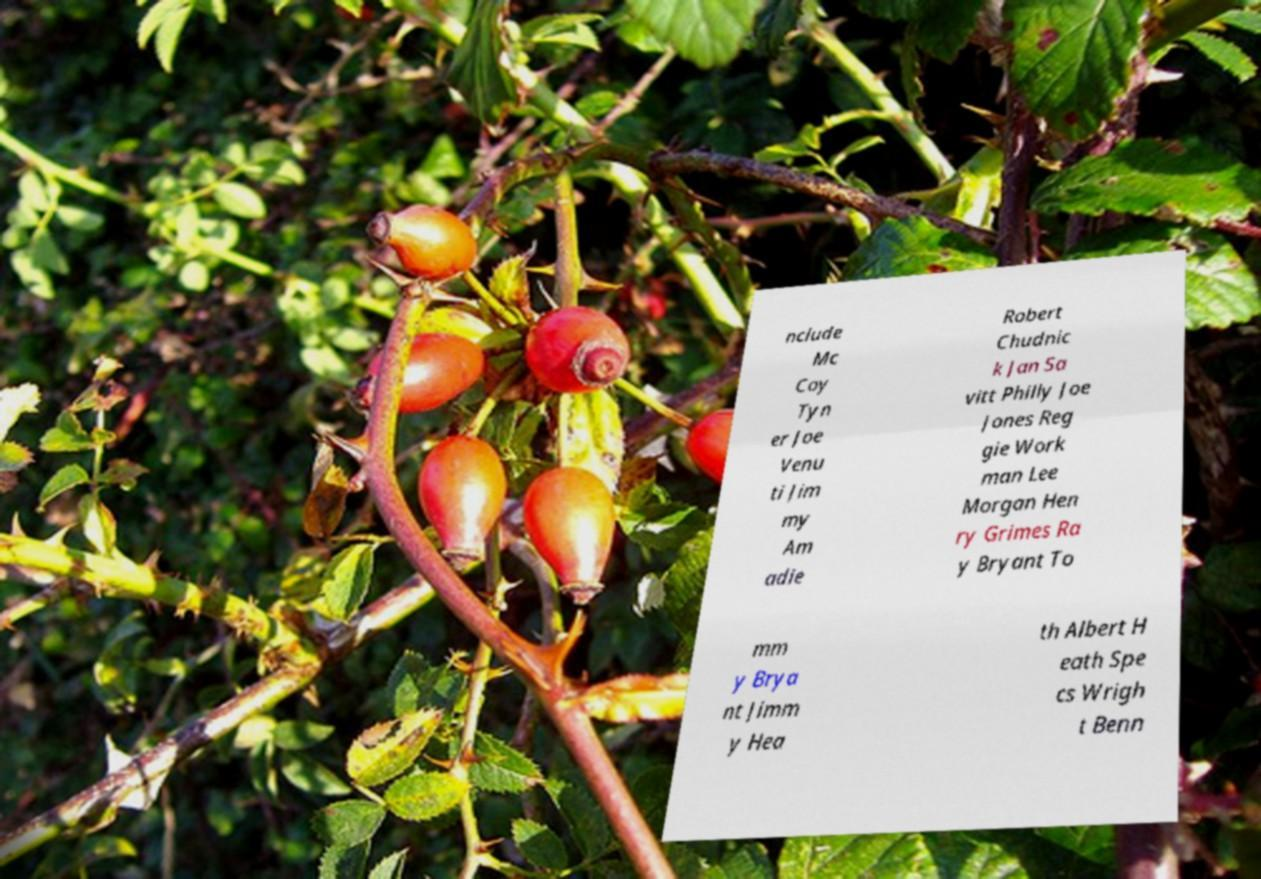There's text embedded in this image that I need extracted. Can you transcribe it verbatim? nclude Mc Coy Tyn er Joe Venu ti Jim my Am adie Robert Chudnic k Jan Sa vitt Philly Joe Jones Reg gie Work man Lee Morgan Hen ry Grimes Ra y Bryant To mm y Brya nt Jimm y Hea th Albert H eath Spe cs Wrigh t Benn 